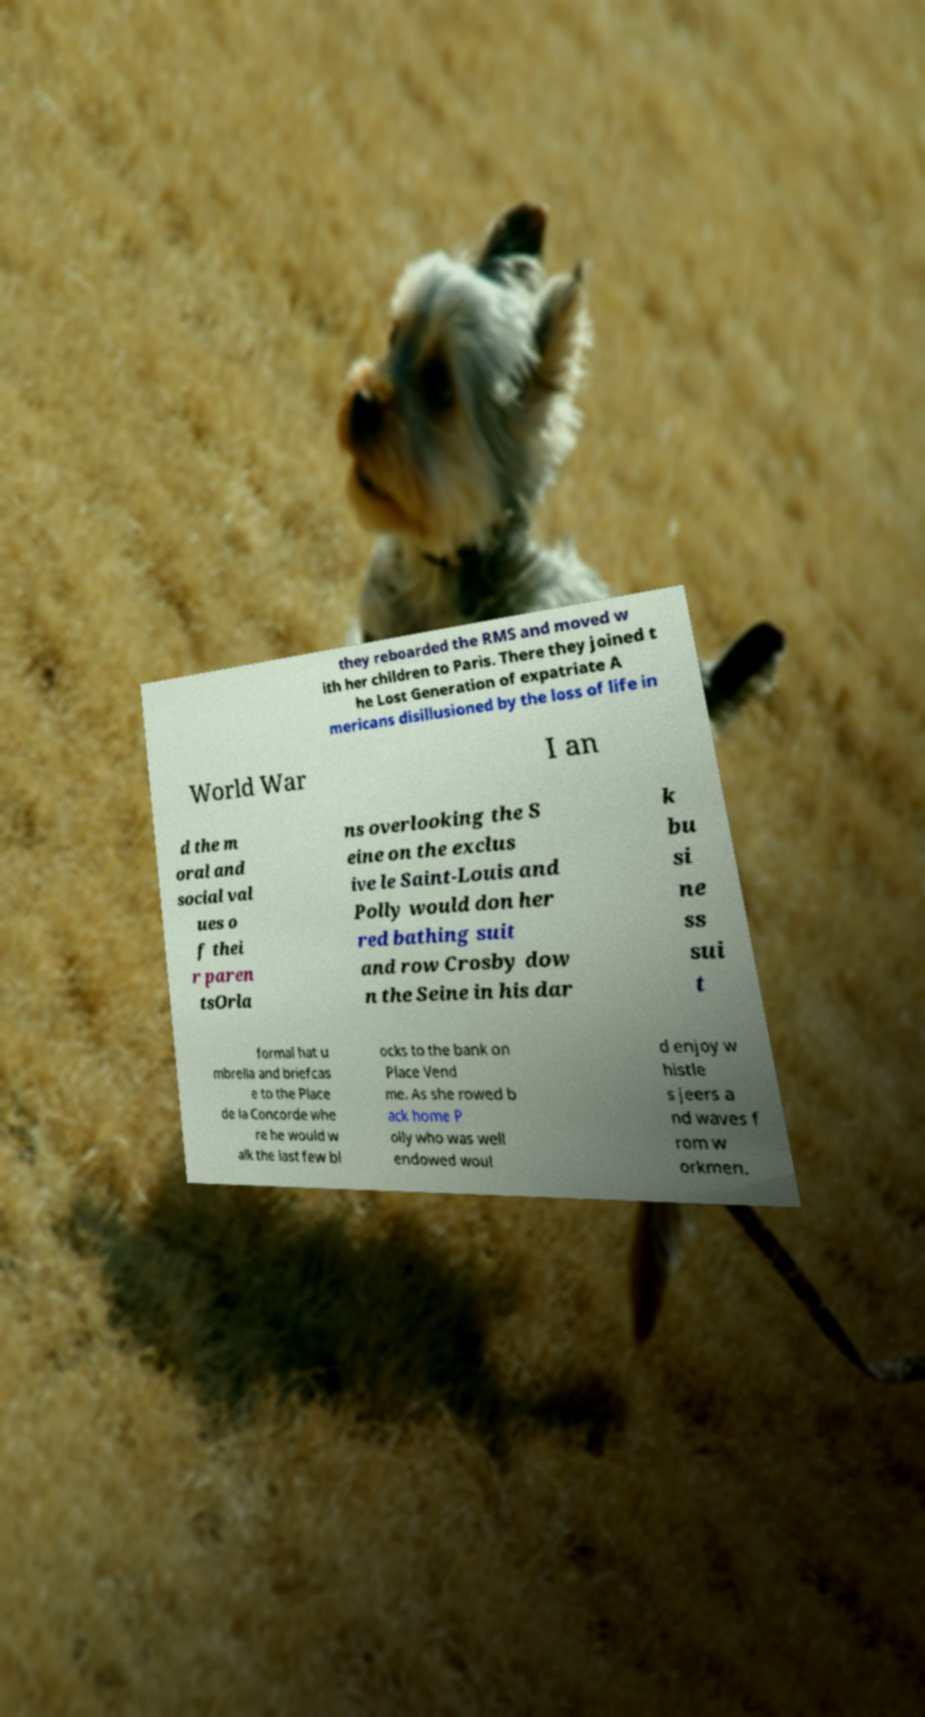Can you accurately transcribe the text from the provided image for me? they reboarded the RMS and moved w ith her children to Paris. There they joined t he Lost Generation of expatriate A mericans disillusioned by the loss of life in World War I an d the m oral and social val ues o f thei r paren tsOrla ns overlooking the S eine on the exclus ive le Saint-Louis and Polly would don her red bathing suit and row Crosby dow n the Seine in his dar k bu si ne ss sui t formal hat u mbrella and briefcas e to the Place de la Concorde whe re he would w alk the last few bl ocks to the bank on Place Vend me. As she rowed b ack home P olly who was well endowed woul d enjoy w histle s jeers a nd waves f rom w orkmen. 